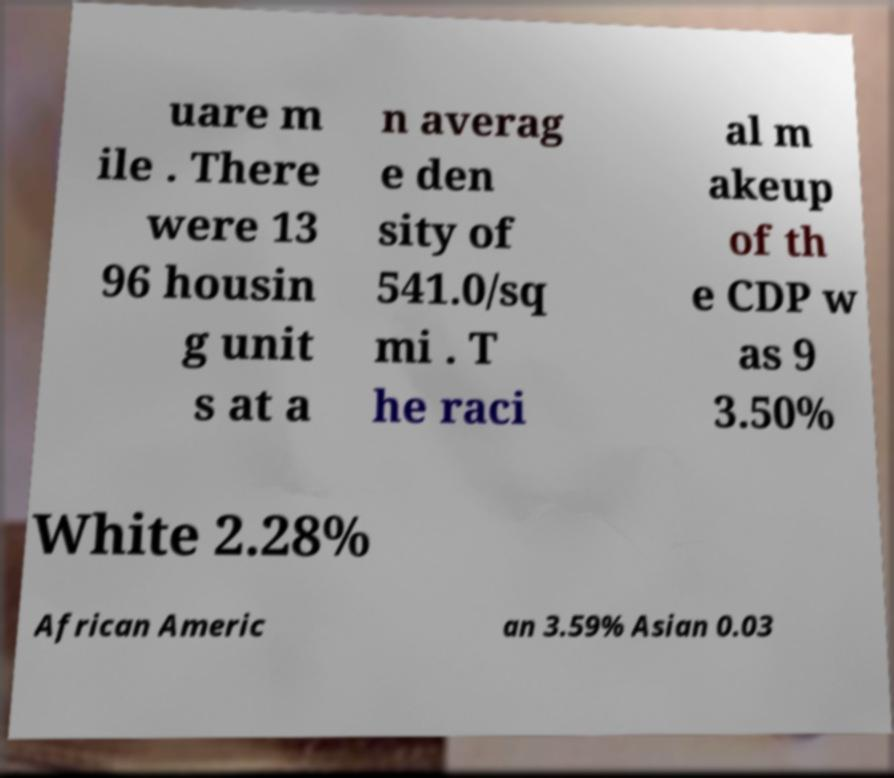There's text embedded in this image that I need extracted. Can you transcribe it verbatim? uare m ile . There were 13 96 housin g unit s at a n averag e den sity of 541.0/sq mi . T he raci al m akeup of th e CDP w as 9 3.50% White 2.28% African Americ an 3.59% Asian 0.03 